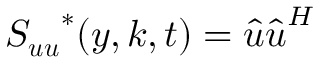<formula> <loc_0><loc_0><loc_500><loc_500>S _ { u u } ^ { * } ( y , k , t ) = \hat { u } \hat { u } ^ { H }</formula> 